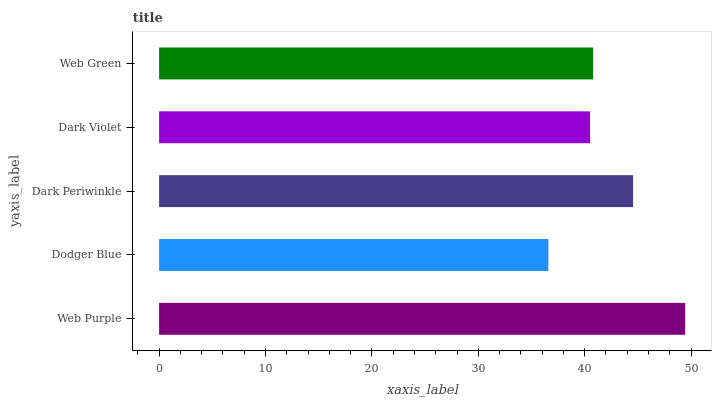Is Dodger Blue the minimum?
Answer yes or no. Yes. Is Web Purple the maximum?
Answer yes or no. Yes. Is Dark Periwinkle the minimum?
Answer yes or no. No. Is Dark Periwinkle the maximum?
Answer yes or no. No. Is Dark Periwinkle greater than Dodger Blue?
Answer yes or no. Yes. Is Dodger Blue less than Dark Periwinkle?
Answer yes or no. Yes. Is Dodger Blue greater than Dark Periwinkle?
Answer yes or no. No. Is Dark Periwinkle less than Dodger Blue?
Answer yes or no. No. Is Web Green the high median?
Answer yes or no. Yes. Is Web Green the low median?
Answer yes or no. Yes. Is Web Purple the high median?
Answer yes or no. No. Is Web Purple the low median?
Answer yes or no. No. 